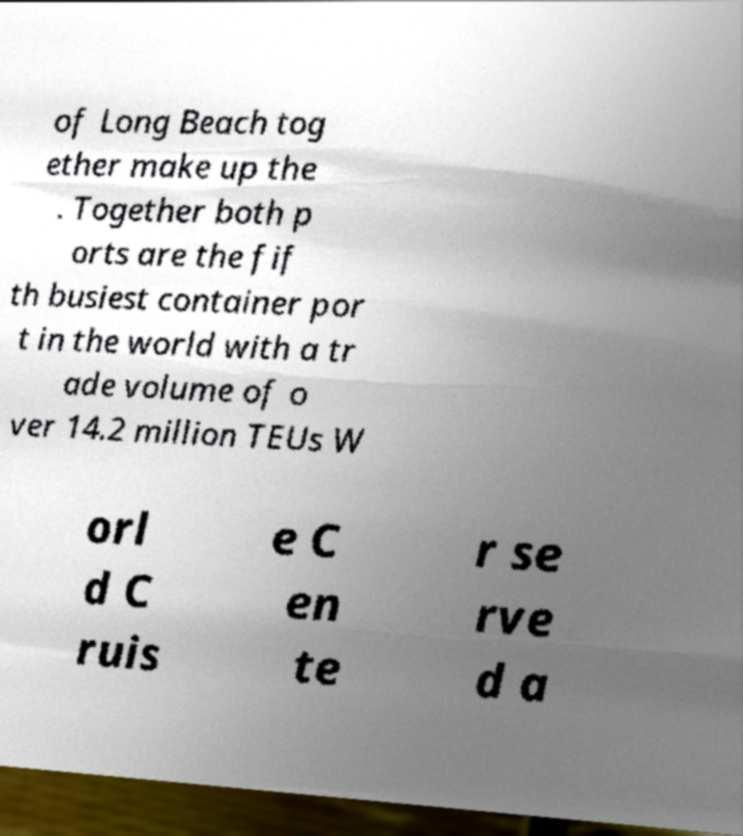Could you extract and type out the text from this image? of Long Beach tog ether make up the . Together both p orts are the fif th busiest container por t in the world with a tr ade volume of o ver 14.2 million TEUs W orl d C ruis e C en te r se rve d a 